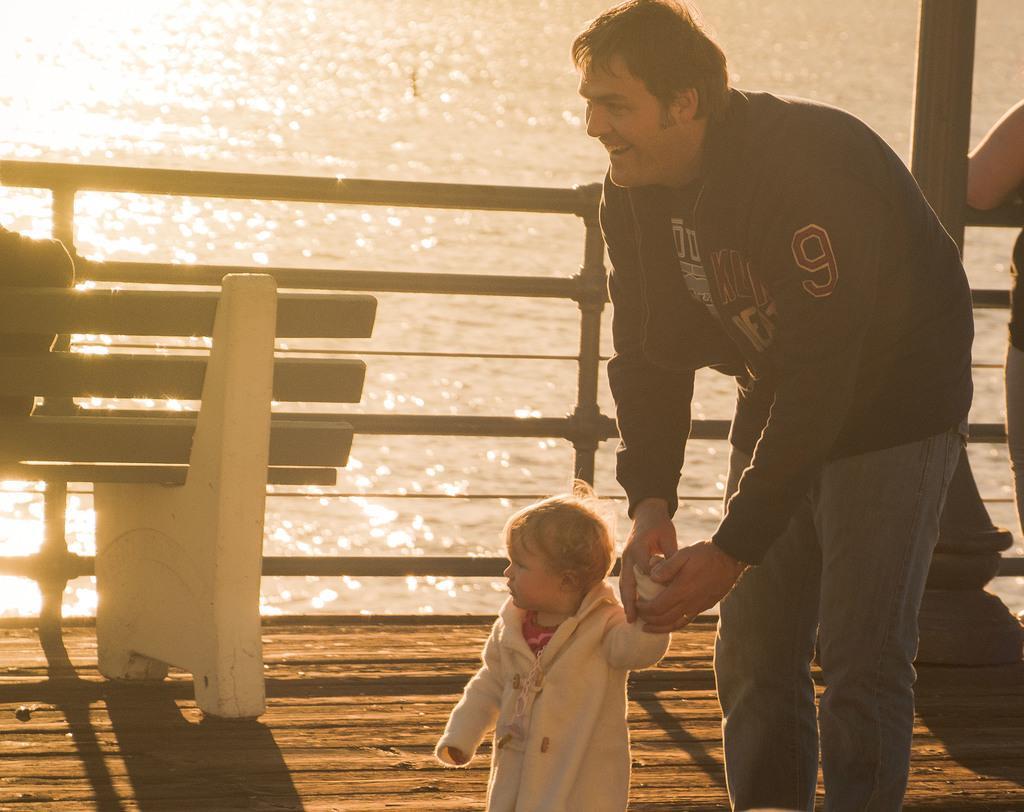Describe this image in one or two sentences. In this image, we can see a person smiling and holding a baby, who is wearing a coat. In the background, there is a bench and we can see railing, pole and an other person. At the bottom, there is wood. In the background, there is water. 